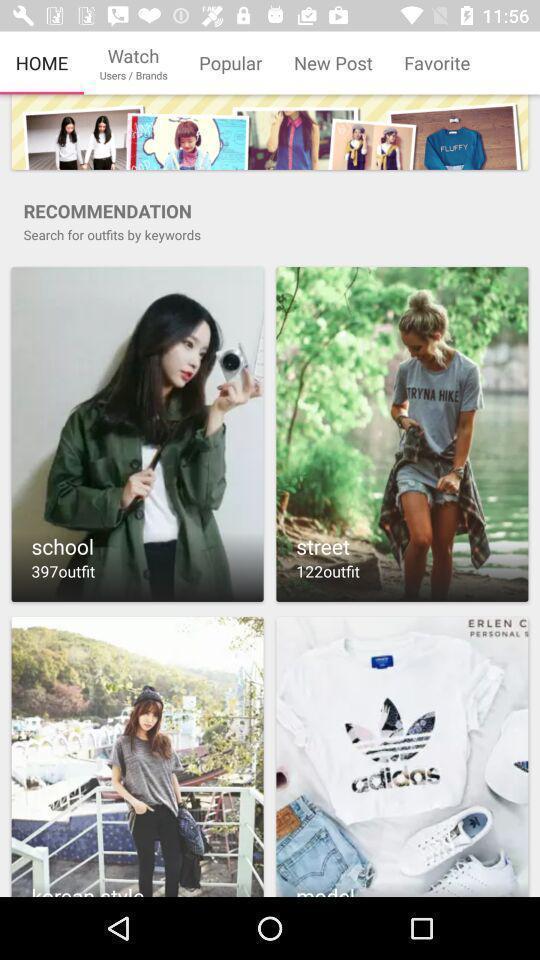Summarize the information in this screenshot. Screen displaying the home page with multiple images. 